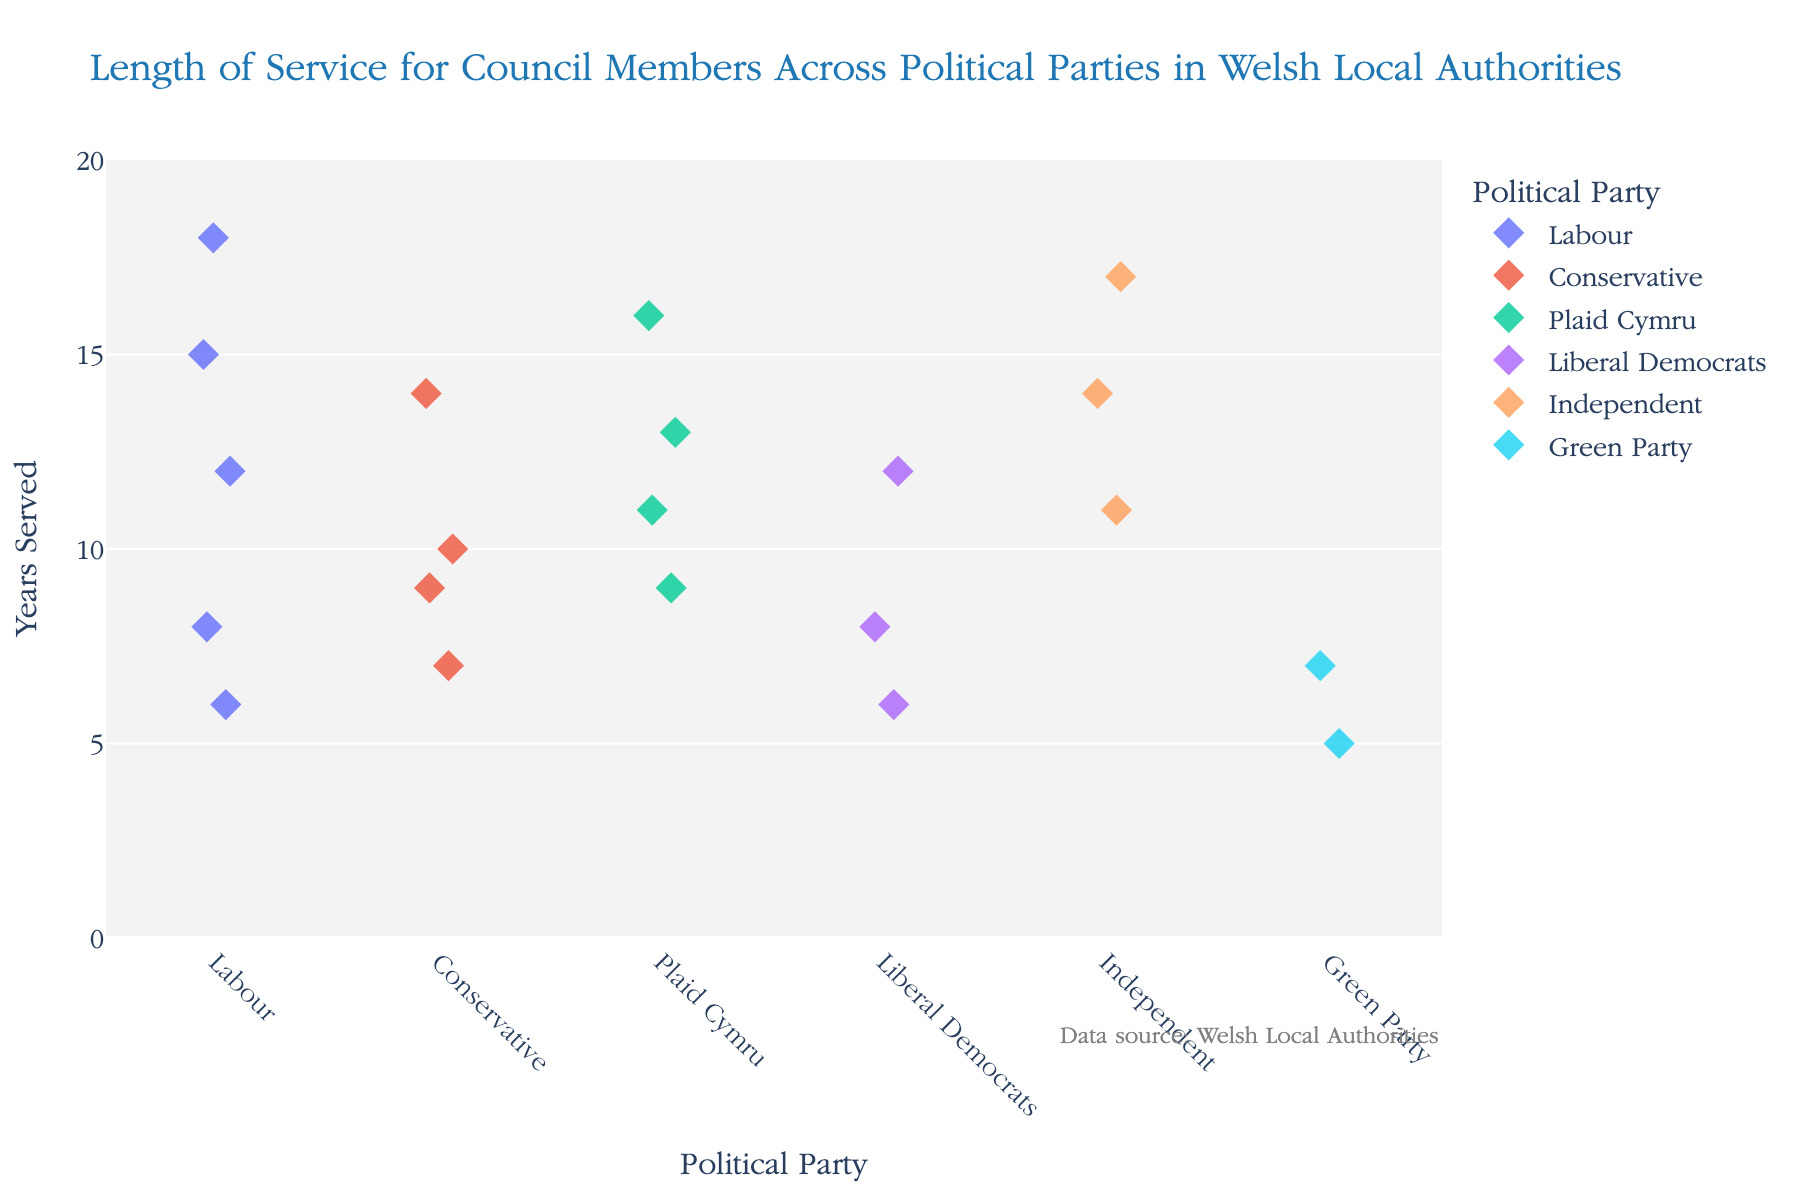What is the title of the plot? The title appears at the top of the plot and gives a brief description of what the plot depicts. In this case, it is displayed as "Length of Service for Council Members Across Political Parties in Welsh Local Authorities."
Answer: Length of Service for Council Members Across Political Parties in Welsh Local Authorities How many council members are represented from the Green Party? By looking at the strip plot, we can count the number of data points (diamond markers) under the "Green Party" on the x-axis.
Answer: 2 Which party has the longest individual service duration, and what is it? Observe the y-axis values for each party and find the highest data point. The highest point is for the Labour party with a service duration of 18 years.
Answer: Labour, 18 years What is the range of years served by the Independent party members? Identify the lowest and highest data points for the Independent party on the y-axis. The lowest is 11 years and the highest is 17 years, giving a range of 17 - 11 = 6 years.
Answer: 6 years How do the lengths of service compare between Labour and Conservative members? Compare the distribution of data points for Labour and Conservative parties. Labour shows a broader range from 6 to 18 years, whereas Conservative has a range from 7 to 14 years. Labour members generally have a greater range of service duration.
Answer: Labour has a broader range of service duration What is the median length of service for Plaid Cymru members? List the service durations for Plaid Cymru (9, 11, 13, 16), and arrange them in ascending order (9, 11, 13, 16). Since there is an even number of data points, the median is the average of the two middle values (11+13)/2 = 12.
Answer: 12 Which party has the highest variability in the length of service among its members? Assess the spread of data points for each party. Labour's lengths of service range from 6 to 18 years (a span of 12 years), indicating the highest variability among the parties.
Answer: Labour Are there any parties where all members served fewer than 10 years? Check each party to see if all data points fall below 10 years on the y-axis. The Green Party is the only party where all members (values 5 and 7) served fewer than 10 years.
Answer: Green Party What is the average length of service for Liberal Democrats? List the service durations for Liberal Democrats (6, 8, 12), sum them (6+8+12=26), and divide by the number of members (3) to find the average. The average length of service is 26/3, which is approximately 8.67 years.
Answer: 8.67 years 